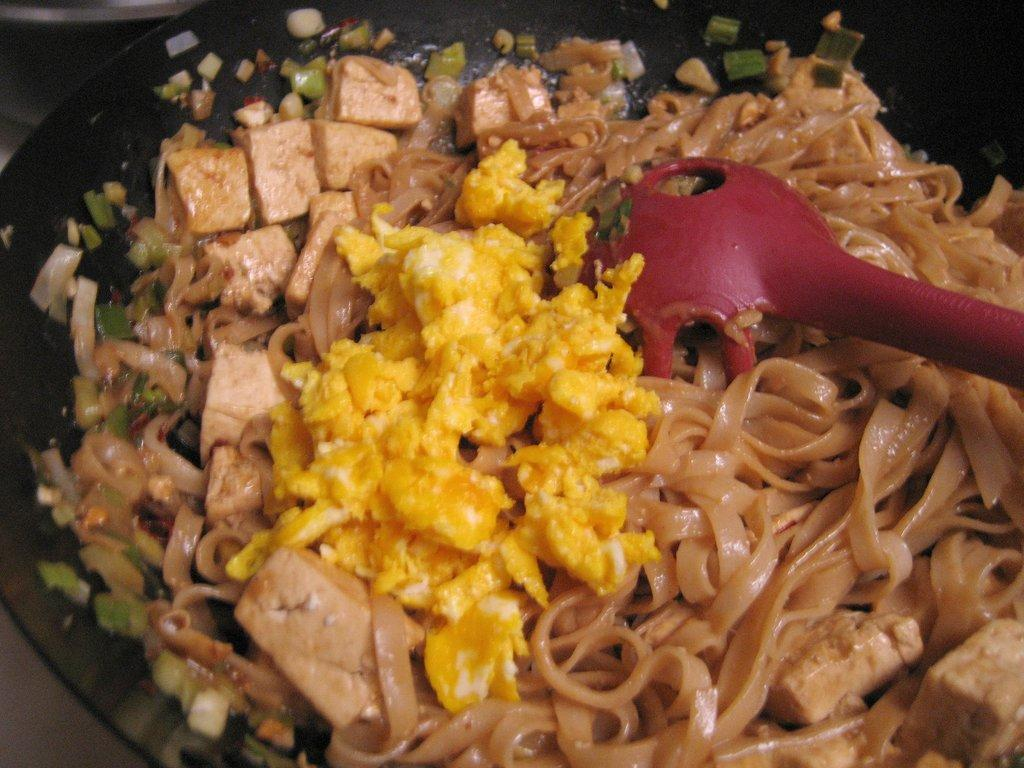What can be seen in the pane in the image? There is a pane containing food in the image. What utensil is visible on the right side of the image? There is a spatula on the right side of the image. How many shoes can be seen in the image? There are no shoes present in the image. Is there a prison visible in the image? There is no prison present in the image. 